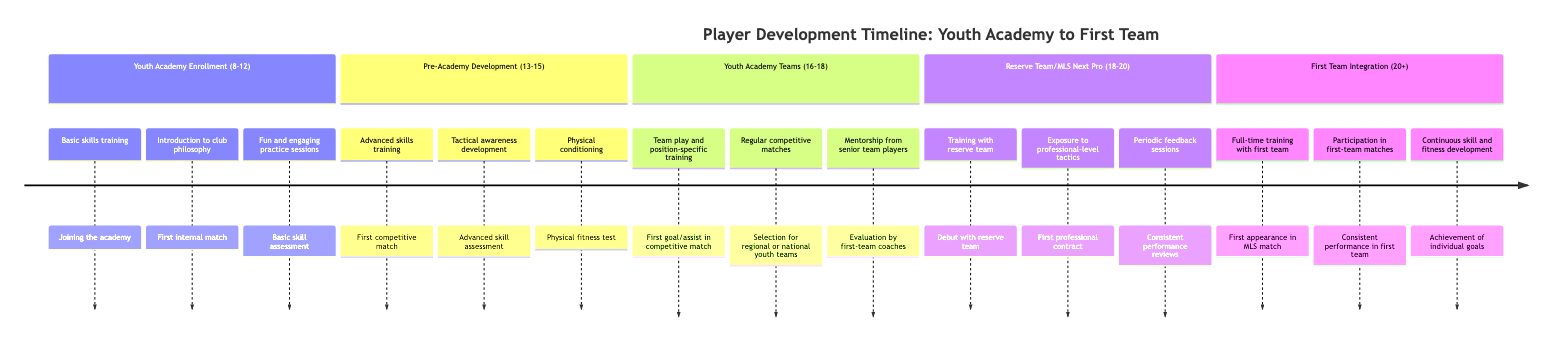What is the age range for Youth Academy Enrollment? The data specifies that the age range for the Youth Academy Enrollment stage is 8-12.
Answer: 8-12 What is the first milestone in Pre-Academy Development? According to the timeline, the first milestone during Pre-Academy Development is the First competitive match.
Answer: First competitive match What activity occurs during the Youth Academy Teams stage? The activities listed for the Youth Academy Teams stage include Team play and position-specific training.
Answer: Team play and position-specific training How many milestones are listed for the First Team Integration stage? Counting the milestones listed under First Team Integration, there are three milestones: First appearance in MLS match, Consistent performance in first team, and Achievement of individual goals.
Answer: 3 What milestone indicates a player's first contract in the Reserve Team/MLS Next Pro stage? The milestone that indicates a player's first contract during this stage is First professional contract.
Answer: First professional contract Which activities contribute to a player's development in the age range of 13-15? The activities for the age range of 13-15 include Advanced skills training, Tactical awareness development, and Physical conditioning.
Answer: Advanced skills training, Tactical awareness development, Physical conditioning What is the last milestone achieved in Youth Academy Teams? The last milestone listed for the Youth Academy Teams stage is Evaluation by first-team coaches.
Answer: Evaluation by first-team coaches Which age range corresponds to the Reserve Team/MLS Next Pro stage? The data shows that the age range for the Reserve Team/MLS Next Pro stage is 18-20.
Answer: 18-20 What is the main focus of activities during the First Team Integration stage? The main focus of activities during this stage includes Full-time training with first team and Participation in first-team matches.
Answer: Full-time training with first team and Participation in first-team matches 